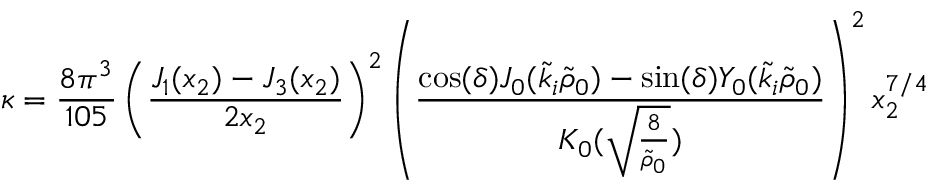Convert formula to latex. <formula><loc_0><loc_0><loc_500><loc_500>\kappa = \frac { 8 \pi ^ { 3 } } { 1 0 5 } \left ( \frac { J _ { 1 } ( x _ { 2 } ) - J _ { 3 } ( x _ { 2 } ) } { 2 x _ { 2 } } \right ) ^ { 2 } \left ( \frac { \cos ( \delta ) J _ { 0 } ( \tilde { k } _ { i } \tilde { \rho } _ { 0 } ) - \sin ( \delta ) Y _ { 0 } ( \tilde { k } _ { i } \tilde { \rho } _ { 0 } ) } { K _ { 0 } ( \sqrt { \frac { 8 } { \tilde { \rho } _ { 0 } } } ) } \right ) ^ { 2 } x _ { 2 } ^ { 7 / 4 }</formula> 